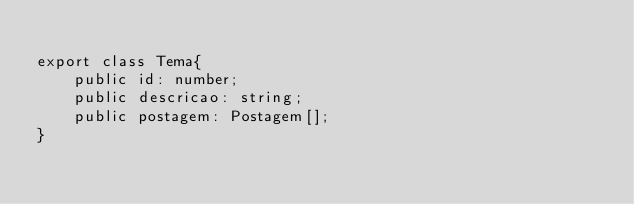Convert code to text. <code><loc_0><loc_0><loc_500><loc_500><_TypeScript_>
export class Tema{
    public id: number;
    public descricao: string;
    public postagem: Postagem[];
}</code> 